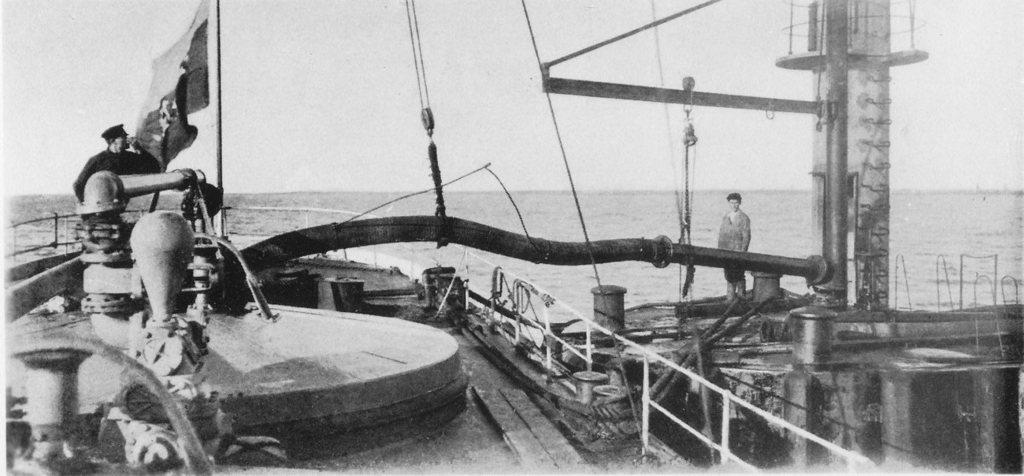In one or two sentences, can you explain what this image depicts? This is a black and white image, in this image at the bottom there is one ship and in that ship there are some machines, ropes and some objects. And also there is one person beside him there is one pole and flag, on the right side there are some wooden sticks, one person, ropes and some other objects. In the background there is a sea. 